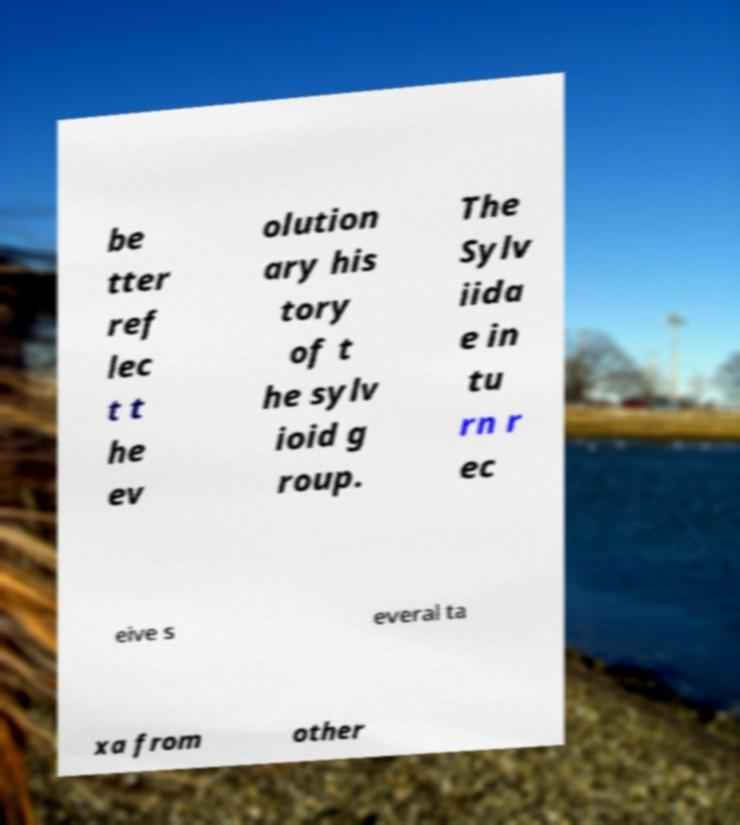I need the written content from this picture converted into text. Can you do that? be tter ref lec t t he ev olution ary his tory of t he sylv ioid g roup. The Sylv iida e in tu rn r ec eive s everal ta xa from other 